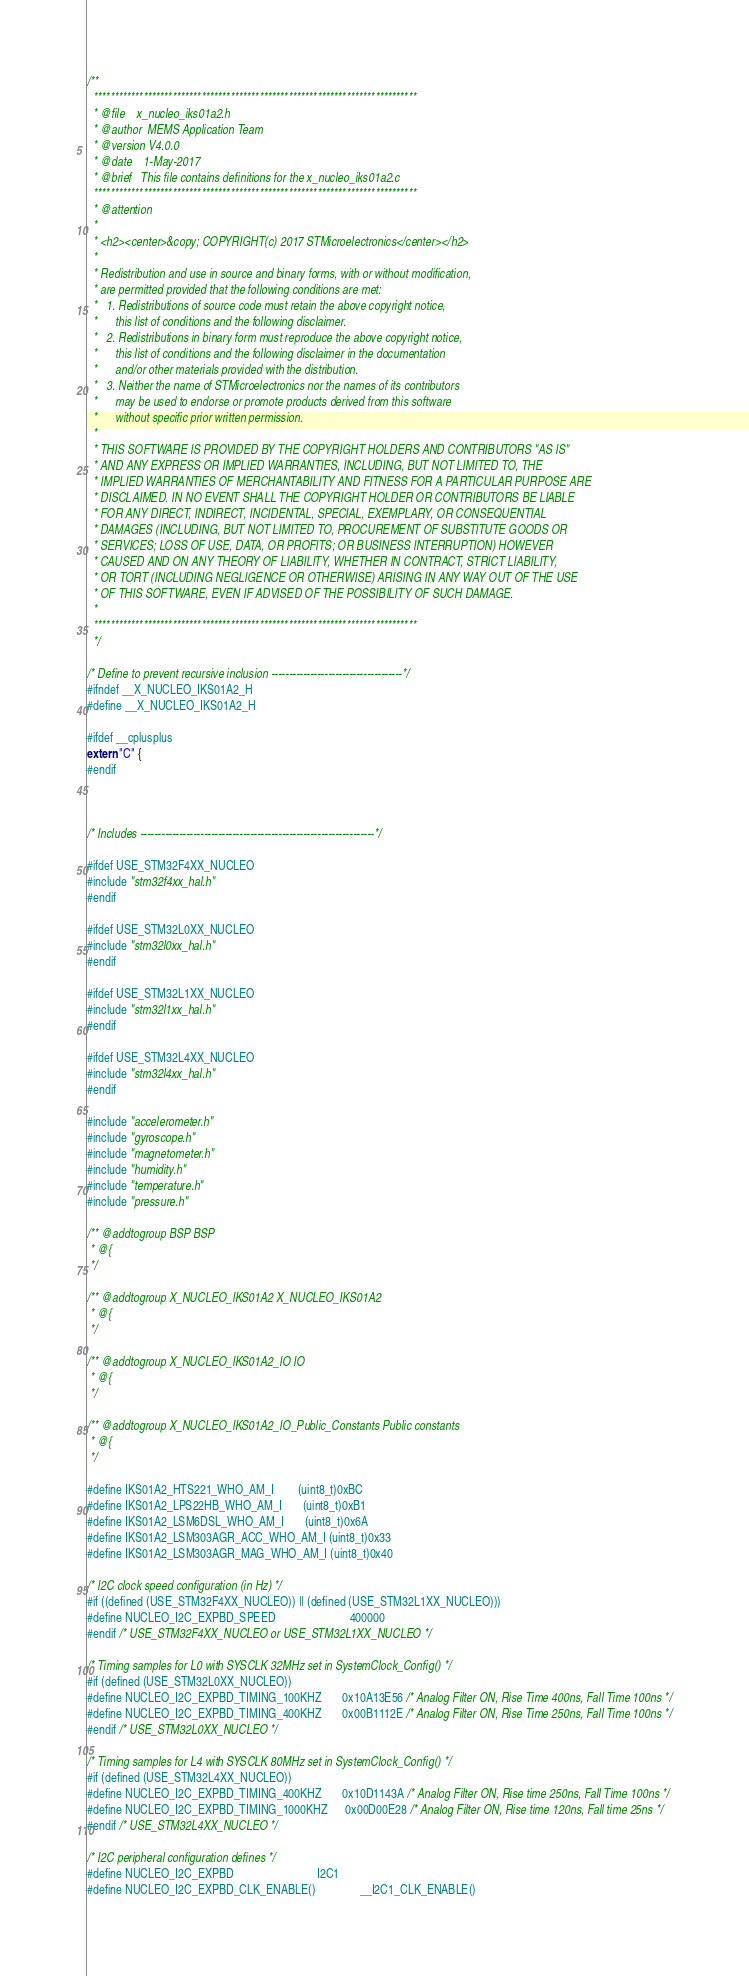Convert code to text. <code><loc_0><loc_0><loc_500><loc_500><_C_>/**
  ******************************************************************************
  * @file    x_nucleo_iks01a2.h
  * @author  MEMS Application Team
  * @version V4.0.0
  * @date    1-May-2017
  * @brief   This file contains definitions for the x_nucleo_iks01a2.c
  ******************************************************************************
  * @attention
  *
  * <h2><center>&copy; COPYRIGHT(c) 2017 STMicroelectronics</center></h2>
  *
  * Redistribution and use in source and binary forms, with or without modification,
  * are permitted provided that the following conditions are met:
  *   1. Redistributions of source code must retain the above copyright notice,
  *      this list of conditions and the following disclaimer.
  *   2. Redistributions in binary form must reproduce the above copyright notice,
  *      this list of conditions and the following disclaimer in the documentation
  *      and/or other materials provided with the distribution.
  *   3. Neither the name of STMicroelectronics nor the names of its contributors
  *      may be used to endorse or promote products derived from this software
  *      without specific prior written permission.
  *
  * THIS SOFTWARE IS PROVIDED BY THE COPYRIGHT HOLDERS AND CONTRIBUTORS "AS IS"
  * AND ANY EXPRESS OR IMPLIED WARRANTIES, INCLUDING, BUT NOT LIMITED TO, THE
  * IMPLIED WARRANTIES OF MERCHANTABILITY AND FITNESS FOR A PARTICULAR PURPOSE ARE
  * DISCLAIMED. IN NO EVENT SHALL THE COPYRIGHT HOLDER OR CONTRIBUTORS BE LIABLE
  * FOR ANY DIRECT, INDIRECT, INCIDENTAL, SPECIAL, EXEMPLARY, OR CONSEQUENTIAL
  * DAMAGES (INCLUDING, BUT NOT LIMITED TO, PROCUREMENT OF SUBSTITUTE GOODS OR
  * SERVICES; LOSS OF USE, DATA, OR PROFITS; OR BUSINESS INTERRUPTION) HOWEVER
  * CAUSED AND ON ANY THEORY OF LIABILITY, WHETHER IN CONTRACT, STRICT LIABILITY,
  * OR TORT (INCLUDING NEGLIGENCE OR OTHERWISE) ARISING IN ANY WAY OUT OF THE USE
  * OF THIS SOFTWARE, EVEN IF ADVISED OF THE POSSIBILITY OF SUCH DAMAGE.
  *
  ******************************************************************************
  */

/* Define to prevent recursive inclusion -------------------------------------*/
#ifndef __X_NUCLEO_IKS01A2_H
#define __X_NUCLEO_IKS01A2_H

#ifdef __cplusplus
extern "C" {
#endif



/* Includes ------------------------------------------------------------------*/

#ifdef USE_STM32F4XX_NUCLEO
#include "stm32f4xx_hal.h"
#endif

#ifdef USE_STM32L0XX_NUCLEO
#include "stm32l0xx_hal.h"
#endif

#ifdef USE_STM32L1XX_NUCLEO
#include "stm32l1xx_hal.h"
#endif

#ifdef USE_STM32L4XX_NUCLEO
#include "stm32l4xx_hal.h"
#endif

#include "accelerometer.h"
#include "gyroscope.h"
#include "magnetometer.h"
#include "humidity.h"
#include "temperature.h"
#include "pressure.h"

/** @addtogroup BSP BSP
 * @{
 */

/** @addtogroup X_NUCLEO_IKS01A2 X_NUCLEO_IKS01A2
 * @{
 */

/** @addtogroup X_NUCLEO_IKS01A2_IO IO
 * @{
 */

/** @addtogroup X_NUCLEO_IKS01A2_IO_Public_Constants Public constants
 * @{
 */

#define IKS01A2_HTS221_WHO_AM_I        (uint8_t)0xBC
#define IKS01A2_LPS22HB_WHO_AM_I       (uint8_t)0xB1
#define IKS01A2_LSM6DSL_WHO_AM_I       (uint8_t)0x6A
#define IKS01A2_LSM303AGR_ACC_WHO_AM_I (uint8_t)0x33
#define IKS01A2_LSM303AGR_MAG_WHO_AM_I (uint8_t)0x40
 
/* I2C clock speed configuration (in Hz) */
#if ((defined (USE_STM32F4XX_NUCLEO)) || (defined (USE_STM32L1XX_NUCLEO)))
#define NUCLEO_I2C_EXPBD_SPEED                         400000
#endif /* USE_STM32F4XX_NUCLEO or USE_STM32L1XX_NUCLEO */

/* Timing samples for L0 with SYSCLK 32MHz set in SystemClock_Config() */
#if (defined (USE_STM32L0XX_NUCLEO))
#define NUCLEO_I2C_EXPBD_TIMING_100KHZ       0x10A13E56 /* Analog Filter ON, Rise Time 400ns, Fall Time 100ns */
#define NUCLEO_I2C_EXPBD_TIMING_400KHZ       0x00B1112E /* Analog Filter ON, Rise Time 250ns, Fall Time 100ns */
#endif /* USE_STM32L0XX_NUCLEO */

/* Timing samples for L4 with SYSCLK 80MHz set in SystemClock_Config() */
#if (defined (USE_STM32L4XX_NUCLEO))
#define NUCLEO_I2C_EXPBD_TIMING_400KHZ       0x10D1143A /* Analog Filter ON, Rise time 250ns, Fall Time 100ns */
#define NUCLEO_I2C_EXPBD_TIMING_1000KHZ      0x00D00E28 /* Analog Filter ON, Rise time 120ns, Fall time 25ns */
#endif /* USE_STM32L4XX_NUCLEO */

/* I2C peripheral configuration defines */
#define NUCLEO_I2C_EXPBD                            I2C1
#define NUCLEO_I2C_EXPBD_CLK_ENABLE()               __I2C1_CLK_ENABLE()</code> 